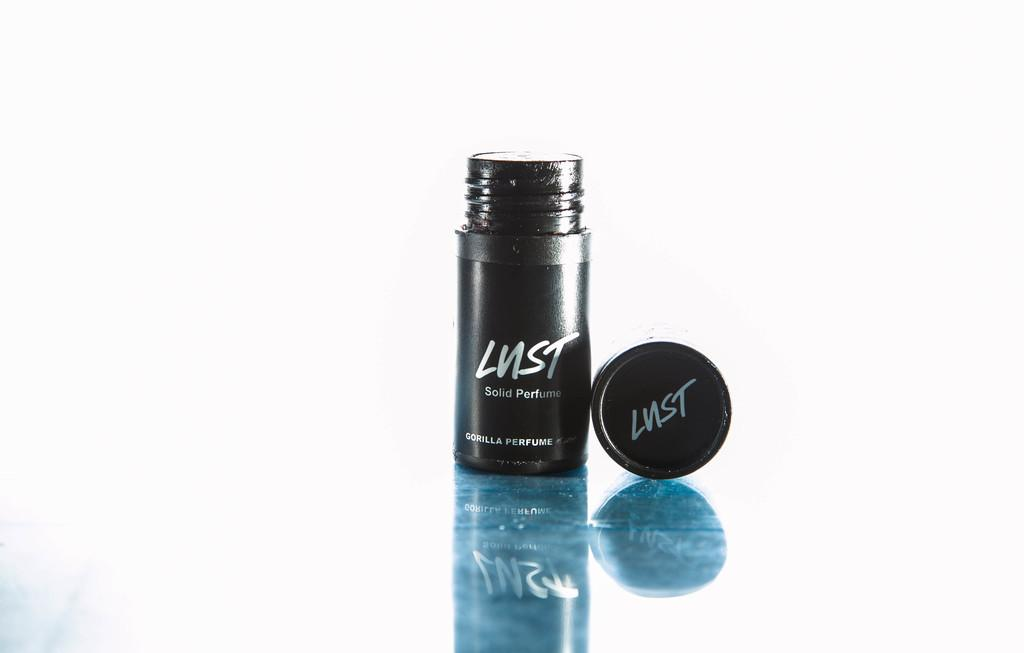<image>
Present a compact description of the photo's key features. A container of something called Lust with its lid off. 